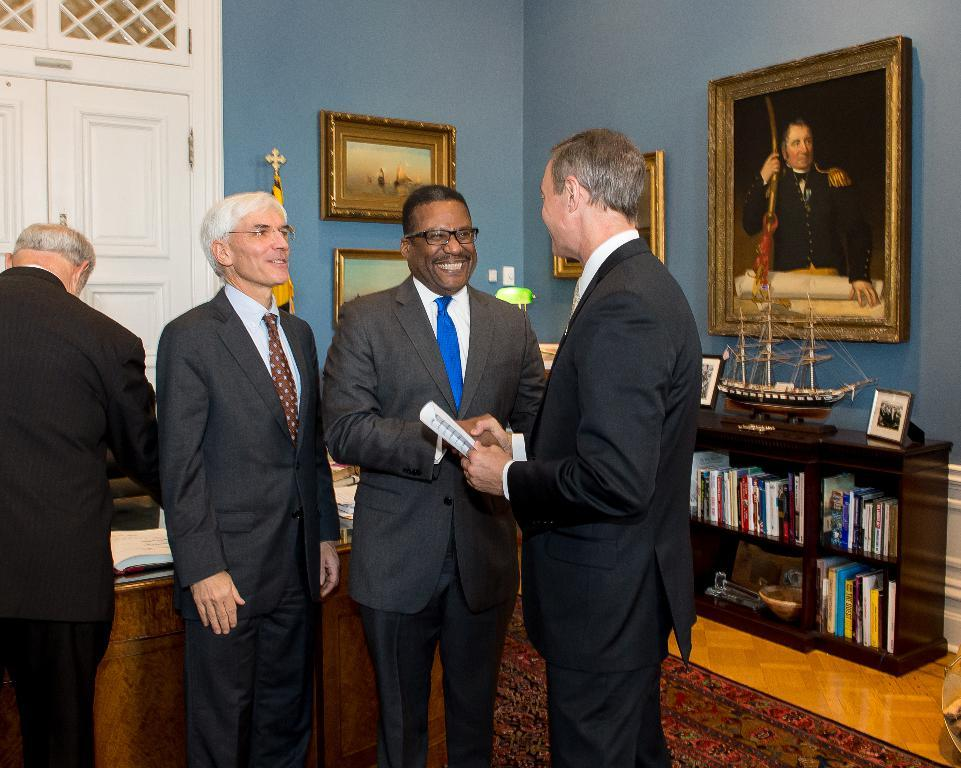What can be seen in the image regarding people? There are men standing in the image. What type of structure is present in the background? There is a wall in the image. What is displayed on the wall? There are photos on the wall. What is the color of the door in the image? There is a white color door in the image. How many basketballs are being twisted by the hour in the image? There are no basketballs or any indication of twisting or hour in the image. 